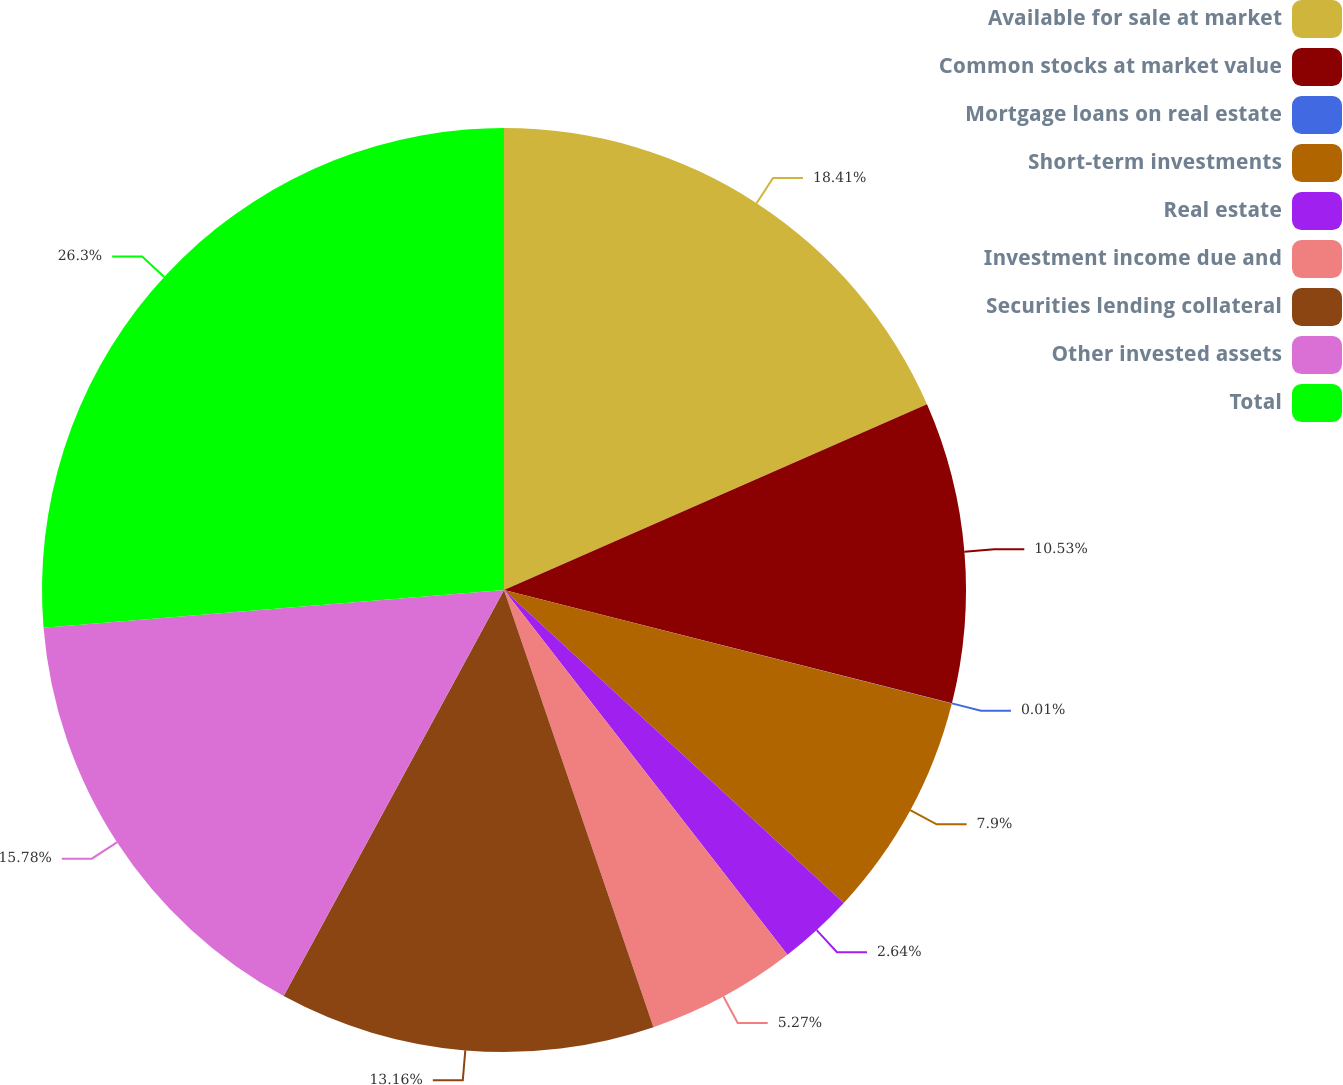Convert chart to OTSL. <chart><loc_0><loc_0><loc_500><loc_500><pie_chart><fcel>Available for sale at market<fcel>Common stocks at market value<fcel>Mortgage loans on real estate<fcel>Short-term investments<fcel>Real estate<fcel>Investment income due and<fcel>Securities lending collateral<fcel>Other invested assets<fcel>Total<nl><fcel>18.42%<fcel>10.53%<fcel>0.01%<fcel>7.9%<fcel>2.64%<fcel>5.27%<fcel>13.16%<fcel>15.79%<fcel>26.31%<nl></chart> 